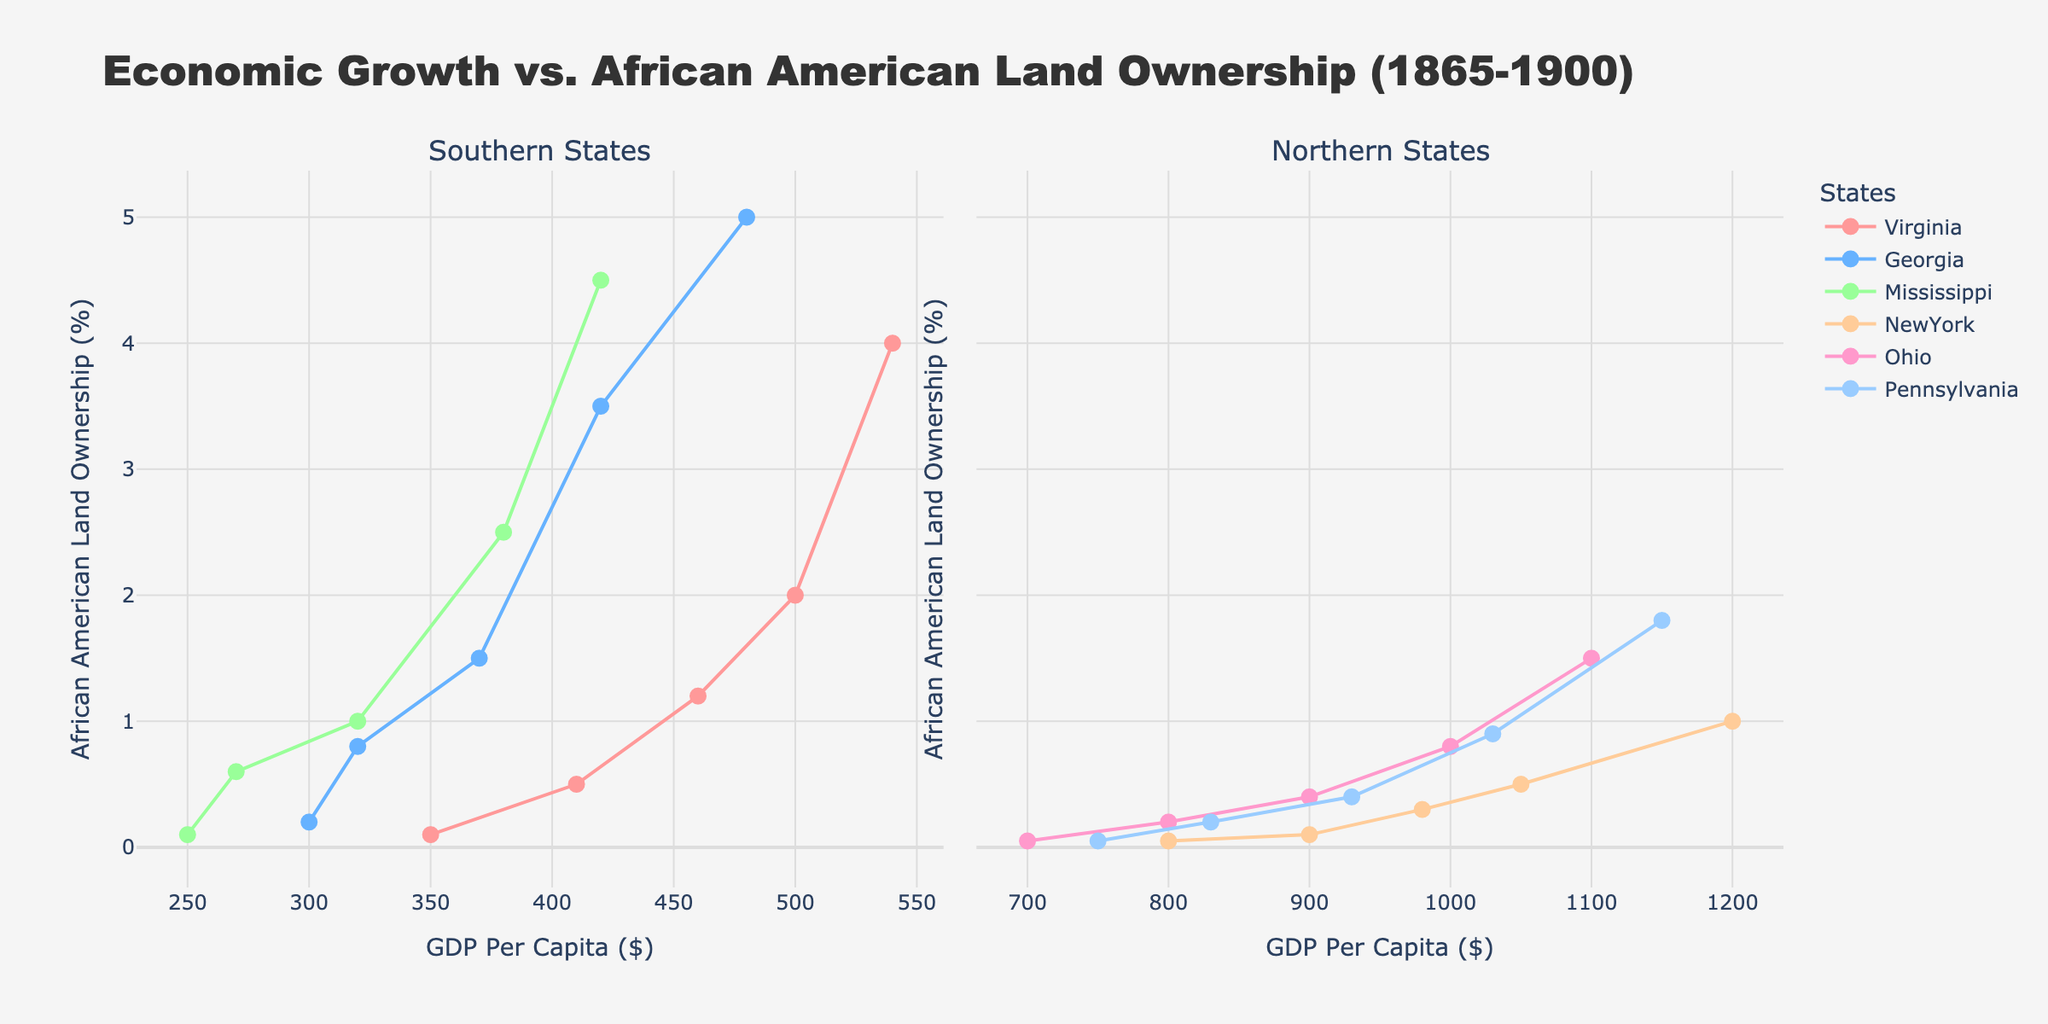What is the title of the figure? The title of the figure is displayed at the top of the plot and indicates what the plot is about. The title reads "Economic Growth vs. African American Land Ownership (1865-1900)."
Answer: Economic Growth vs. African American Land Ownership (1865-1900) Which state has the highest percentage of African American land ownership in the Southern States in 1900? By focusing on the subplot for Southern States and looking at the data points for the year 1900, it's evident that Georgia has the highest percentage of African American land ownership.
Answer: Georgia In the Northern States subplot, which state shows a significant increase in African American land ownership between 1865 and 1900? By examining the subplot for Northern States, New York shows a progression in the percentage of African American land ownership over the years from a low in 1865 to a noticeable increase by 1900.
Answer: New York Among the Southern States, which state had the lowest GDP per capita in 1865 and what was its value? By looking at the data points on the Southern States subplot for 1865, Mississippi has the lowest GDP per capita, which aligns with the lowest vertical position on the x-axis for that year.
Answer: Mississippi, $250 Compare the maximum African American land ownership percentage in Northern and Southern states by 1900. Which region had higher percentages overall? By comparing the highest points in both subplots by 1900, Southern states have a higher percentage of African American land ownership, with the highest being 5% in Georgia. The highest in the Northern states is 1.8% in Pennsylvania.
Answer: Southern states What is the trend of GDP per capita in Virginia from 1865 to 1900? Virginia's data points in the Southern States subplot show a consistent increase in GDP per capita over the years from 1865 to 1900. This is represented by the upward movement of the points along the x-axis from left to right.
Answer: Upward trend Which state had the highest GDP per capita in 1900 in all the states displayed and what was its value? Looking at both subplots in the year 1900, New York has the highest GDP per capita, which is shown as the farthest point on the right on the Northern States subplot.
Answer: New York, $1200 How does the percentage of African American land ownership in Mississippi change from 1865 to 1900? By tracing Mississippi's data points in the Southern States subplot, we see an increase from 0.1% in 1865 to 4.5% in 1900, indicating significant growth over the years.
Answer: Significant growth Between Ohio and Pennsylvania in 1880, which state had a higher percentage of African American land ownership, and by how much? By comparing the data points for Ohio and Pennsylvania in 1880 in the Northern States subplot, Pennsylvania had a land ownership percentage of 0.4%, and Ohio had 0.4%, so they are equal in that year.
Answer: Pennsylvania, 0% What's the average GDP per capita for the Southern States in 1870? The GDP per capita values in 1870 for the Southern States (Virginia: $410, Georgia: $320, Mississippi: $270) are used to find the average: (410 + 320 + 270) / 3 = 1000 / 3 ≈ 333.33
Answer: $333.33 